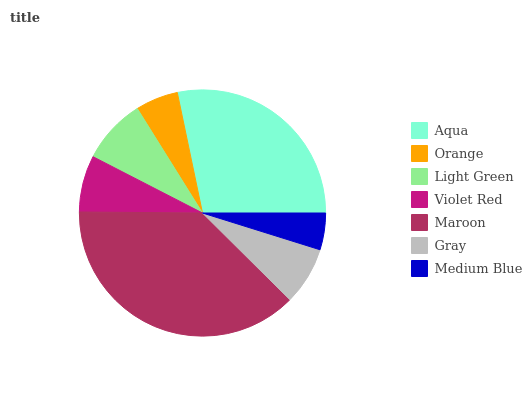Is Medium Blue the minimum?
Answer yes or no. Yes. Is Maroon the maximum?
Answer yes or no. Yes. Is Orange the minimum?
Answer yes or no. No. Is Orange the maximum?
Answer yes or no. No. Is Aqua greater than Orange?
Answer yes or no. Yes. Is Orange less than Aqua?
Answer yes or no. Yes. Is Orange greater than Aqua?
Answer yes or no. No. Is Aqua less than Orange?
Answer yes or no. No. Is Gray the high median?
Answer yes or no. Yes. Is Gray the low median?
Answer yes or no. Yes. Is Light Green the high median?
Answer yes or no. No. Is Medium Blue the low median?
Answer yes or no. No. 